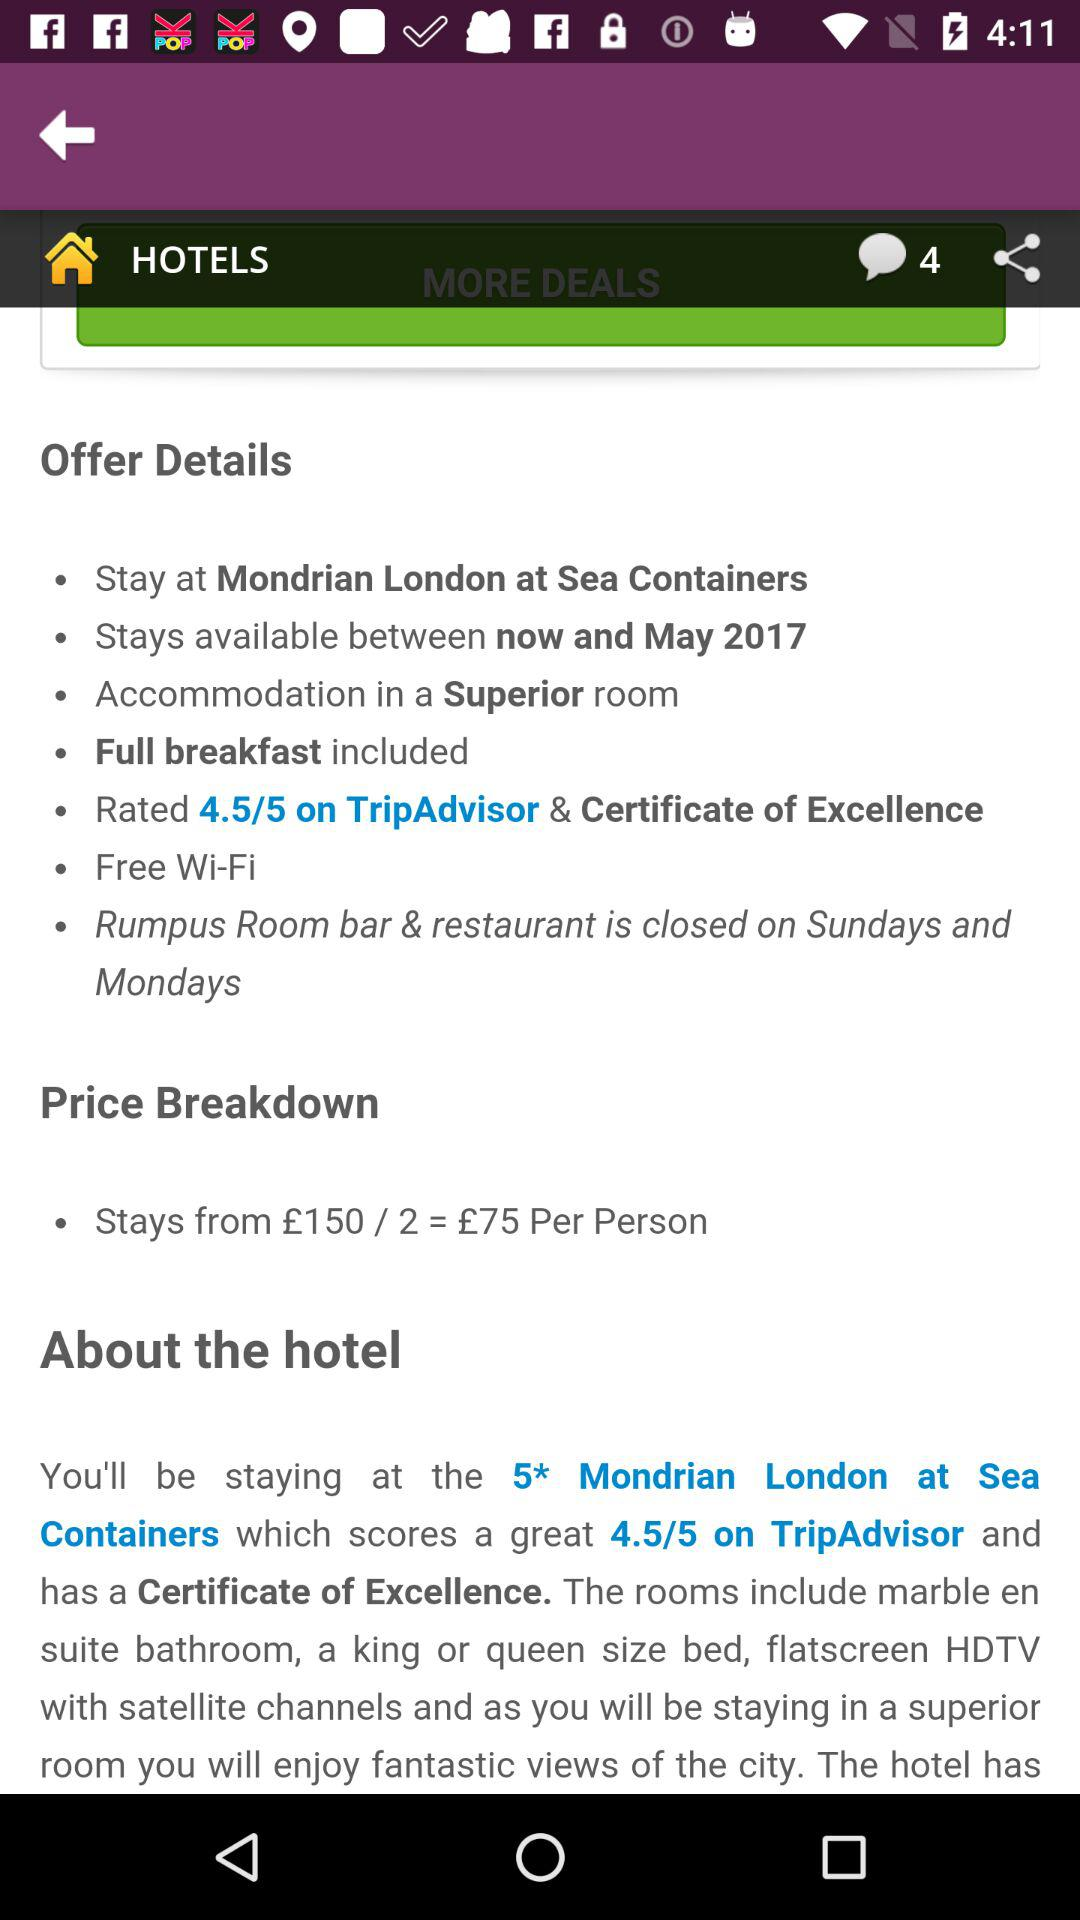What is the price of the room? The price of the room is £75 per person. 